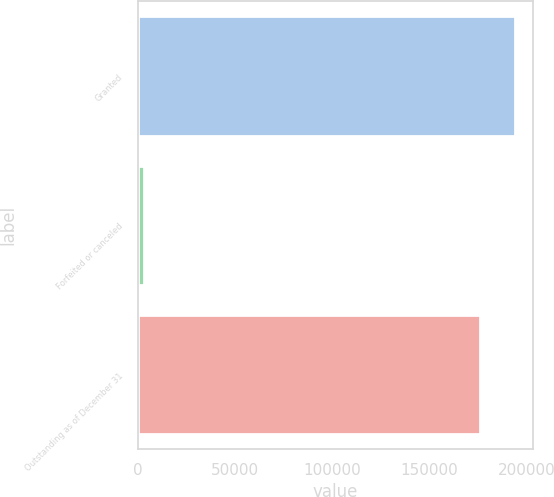Convert chart to OTSL. <chart><loc_0><loc_0><loc_500><loc_500><bar_chart><fcel>Granted<fcel>Forfeited or canceled<fcel>Outstanding as of December 31<nl><fcel>193700<fcel>2915<fcel>176091<nl></chart> 